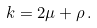Convert formula to latex. <formula><loc_0><loc_0><loc_500><loc_500>k = 2 \mu + \rho { \, } .</formula> 